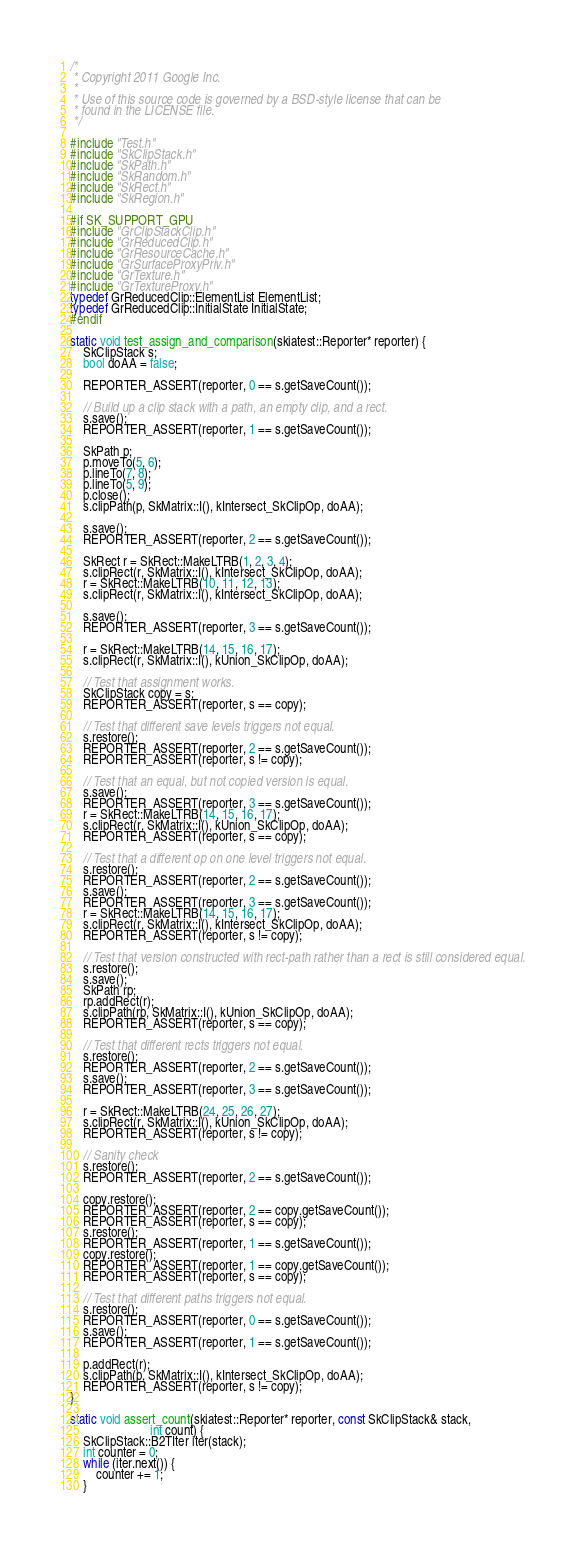<code> <loc_0><loc_0><loc_500><loc_500><_C++_>/*
 * Copyright 2011 Google Inc.
 *
 * Use of this source code is governed by a BSD-style license that can be
 * found in the LICENSE file.
 */

#include "Test.h"
#include "SkClipStack.h"
#include "SkPath.h"
#include "SkRandom.h"
#include "SkRect.h"
#include "SkRegion.h"

#if SK_SUPPORT_GPU
#include "GrClipStackClip.h"
#include "GrReducedClip.h"
#include "GrResourceCache.h"
#include "GrSurfaceProxyPriv.h"
#include "GrTexture.h"
#include "GrTextureProxy.h"
typedef GrReducedClip::ElementList ElementList;
typedef GrReducedClip::InitialState InitialState;
#endif

static void test_assign_and_comparison(skiatest::Reporter* reporter) {
    SkClipStack s;
    bool doAA = false;

    REPORTER_ASSERT(reporter, 0 == s.getSaveCount());

    // Build up a clip stack with a path, an empty clip, and a rect.
    s.save();
    REPORTER_ASSERT(reporter, 1 == s.getSaveCount());

    SkPath p;
    p.moveTo(5, 6);
    p.lineTo(7, 8);
    p.lineTo(5, 9);
    p.close();
    s.clipPath(p, SkMatrix::I(), kIntersect_SkClipOp, doAA);

    s.save();
    REPORTER_ASSERT(reporter, 2 == s.getSaveCount());

    SkRect r = SkRect::MakeLTRB(1, 2, 3, 4);
    s.clipRect(r, SkMatrix::I(), kIntersect_SkClipOp, doAA);
    r = SkRect::MakeLTRB(10, 11, 12, 13);
    s.clipRect(r, SkMatrix::I(), kIntersect_SkClipOp, doAA);

    s.save();
    REPORTER_ASSERT(reporter, 3 == s.getSaveCount());

    r = SkRect::MakeLTRB(14, 15, 16, 17);
    s.clipRect(r, SkMatrix::I(), kUnion_SkClipOp, doAA);

    // Test that assignment works.
    SkClipStack copy = s;
    REPORTER_ASSERT(reporter, s == copy);

    // Test that different save levels triggers not equal.
    s.restore();
    REPORTER_ASSERT(reporter, 2 == s.getSaveCount());
    REPORTER_ASSERT(reporter, s != copy);

    // Test that an equal, but not copied version is equal.
    s.save();
    REPORTER_ASSERT(reporter, 3 == s.getSaveCount());
    r = SkRect::MakeLTRB(14, 15, 16, 17);
    s.clipRect(r, SkMatrix::I(), kUnion_SkClipOp, doAA);
    REPORTER_ASSERT(reporter, s == copy);

    // Test that a different op on one level triggers not equal.
    s.restore();
    REPORTER_ASSERT(reporter, 2 == s.getSaveCount());
    s.save();
    REPORTER_ASSERT(reporter, 3 == s.getSaveCount());
    r = SkRect::MakeLTRB(14, 15, 16, 17);
    s.clipRect(r, SkMatrix::I(), kIntersect_SkClipOp, doAA);
    REPORTER_ASSERT(reporter, s != copy);

    // Test that version constructed with rect-path rather than a rect is still considered equal.
    s.restore();
    s.save();
    SkPath rp;
    rp.addRect(r);
    s.clipPath(rp, SkMatrix::I(), kUnion_SkClipOp, doAA);
    REPORTER_ASSERT(reporter, s == copy);

    // Test that different rects triggers not equal.
    s.restore();
    REPORTER_ASSERT(reporter, 2 == s.getSaveCount());
    s.save();
    REPORTER_ASSERT(reporter, 3 == s.getSaveCount());

    r = SkRect::MakeLTRB(24, 25, 26, 27);
    s.clipRect(r, SkMatrix::I(), kUnion_SkClipOp, doAA);
    REPORTER_ASSERT(reporter, s != copy);

    // Sanity check
    s.restore();
    REPORTER_ASSERT(reporter, 2 == s.getSaveCount());

    copy.restore();
    REPORTER_ASSERT(reporter, 2 == copy.getSaveCount());
    REPORTER_ASSERT(reporter, s == copy);
    s.restore();
    REPORTER_ASSERT(reporter, 1 == s.getSaveCount());
    copy.restore();
    REPORTER_ASSERT(reporter, 1 == copy.getSaveCount());
    REPORTER_ASSERT(reporter, s == copy);

    // Test that different paths triggers not equal.
    s.restore();
    REPORTER_ASSERT(reporter, 0 == s.getSaveCount());
    s.save();
    REPORTER_ASSERT(reporter, 1 == s.getSaveCount());

    p.addRect(r);
    s.clipPath(p, SkMatrix::I(), kIntersect_SkClipOp, doAA);
    REPORTER_ASSERT(reporter, s != copy);
}

static void assert_count(skiatest::Reporter* reporter, const SkClipStack& stack,
                         int count) {
    SkClipStack::B2TIter iter(stack);
    int counter = 0;
    while (iter.next()) {
        counter += 1;
    }</code> 